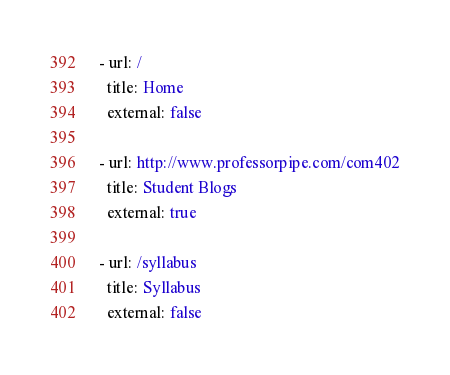<code> <loc_0><loc_0><loc_500><loc_500><_YAML_>- url: /
  title: Home
  external: false

- url: http://www.professorpipe.com/com402
  title: Student Blogs
  external: true
  
- url: /syllabus
  title: Syllabus
  external: false
</code> 